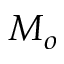Convert formula to latex. <formula><loc_0><loc_0><loc_500><loc_500>M _ { o }</formula> 